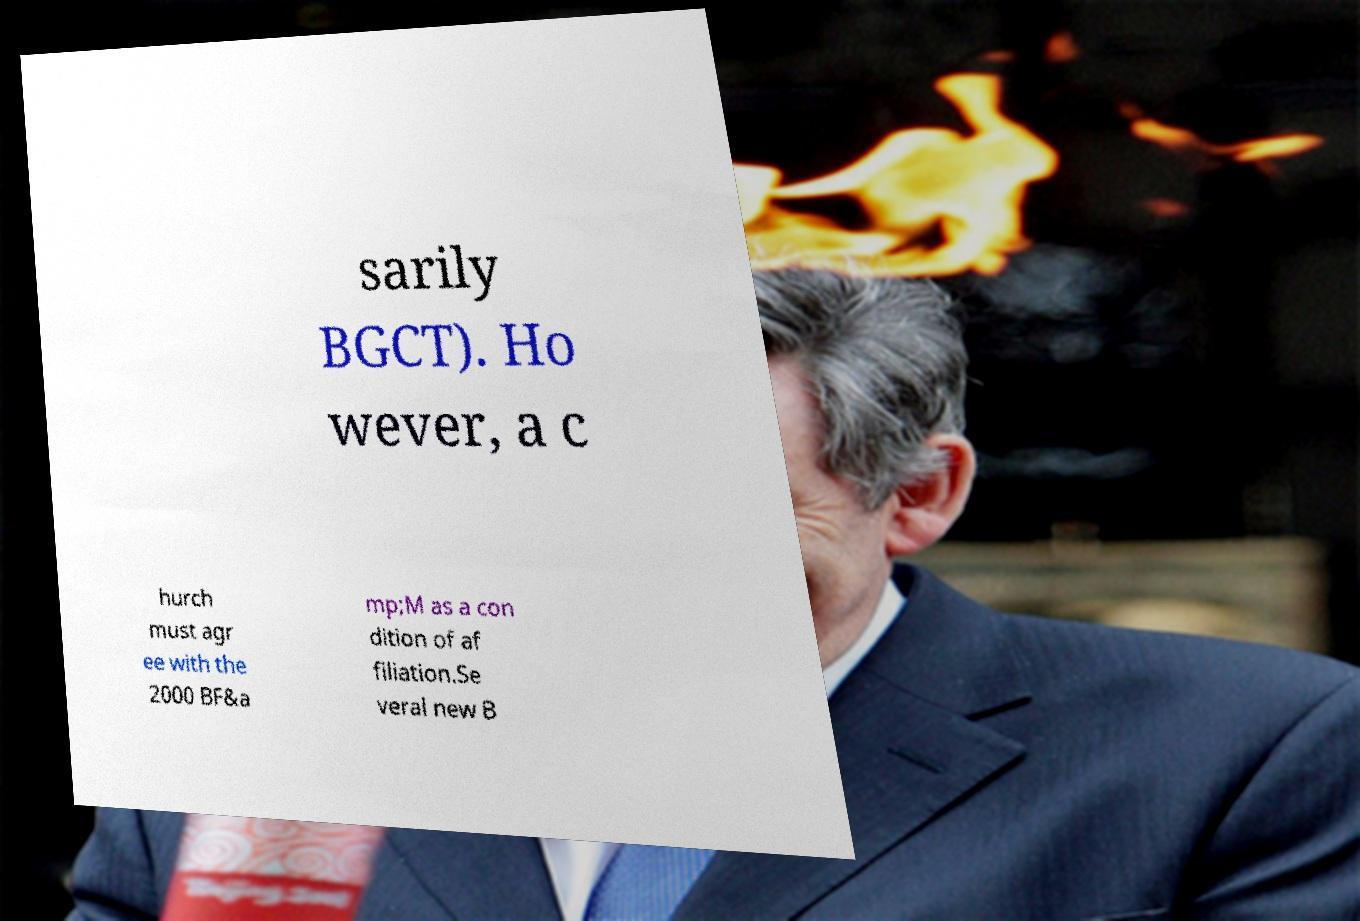Please read and relay the text visible in this image. What does it say? sarily BGCT). Ho wever, a c hurch must agr ee with the 2000 BF&a mp;M as a con dition of af filiation.Se veral new B 